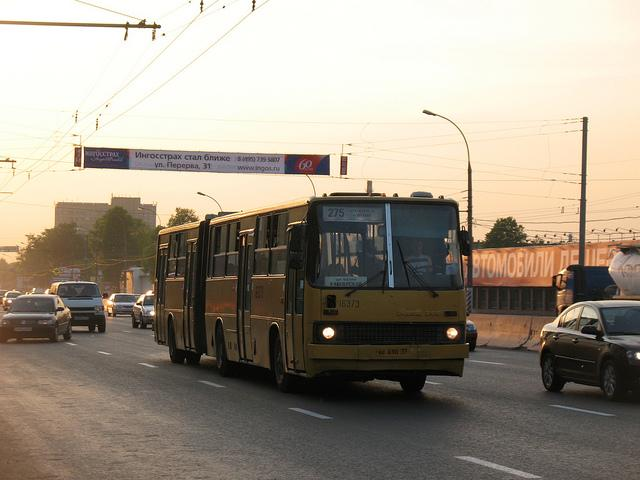What time of day does the bus drive in here?

Choices:
A) noon
B) 1 pm
C) 11 am
D) sunset sunset 